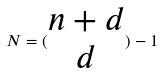<formula> <loc_0><loc_0><loc_500><loc_500>N = ( \begin{matrix} n + d \\ d \end{matrix} ) - 1</formula> 